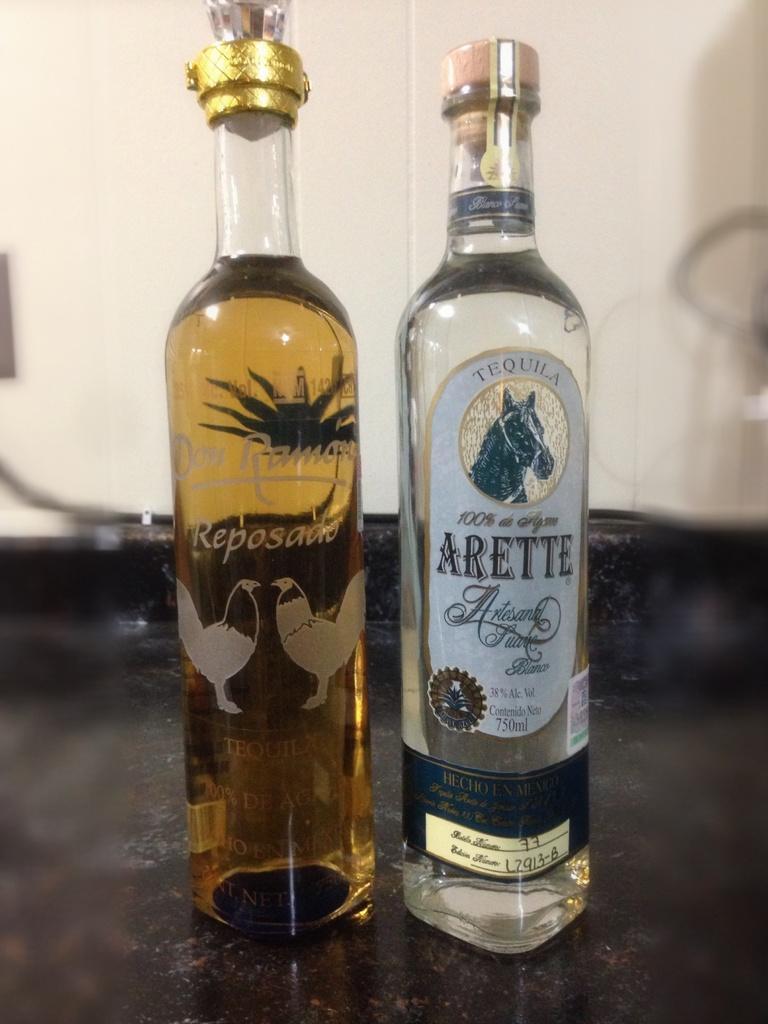Can you describe this image briefly? In this picture i could see two bottles which are filled with some liquid and closed with a lid wooden lid. In the background i could see a yellow colored wall and these bottles are placed on the counter top. 